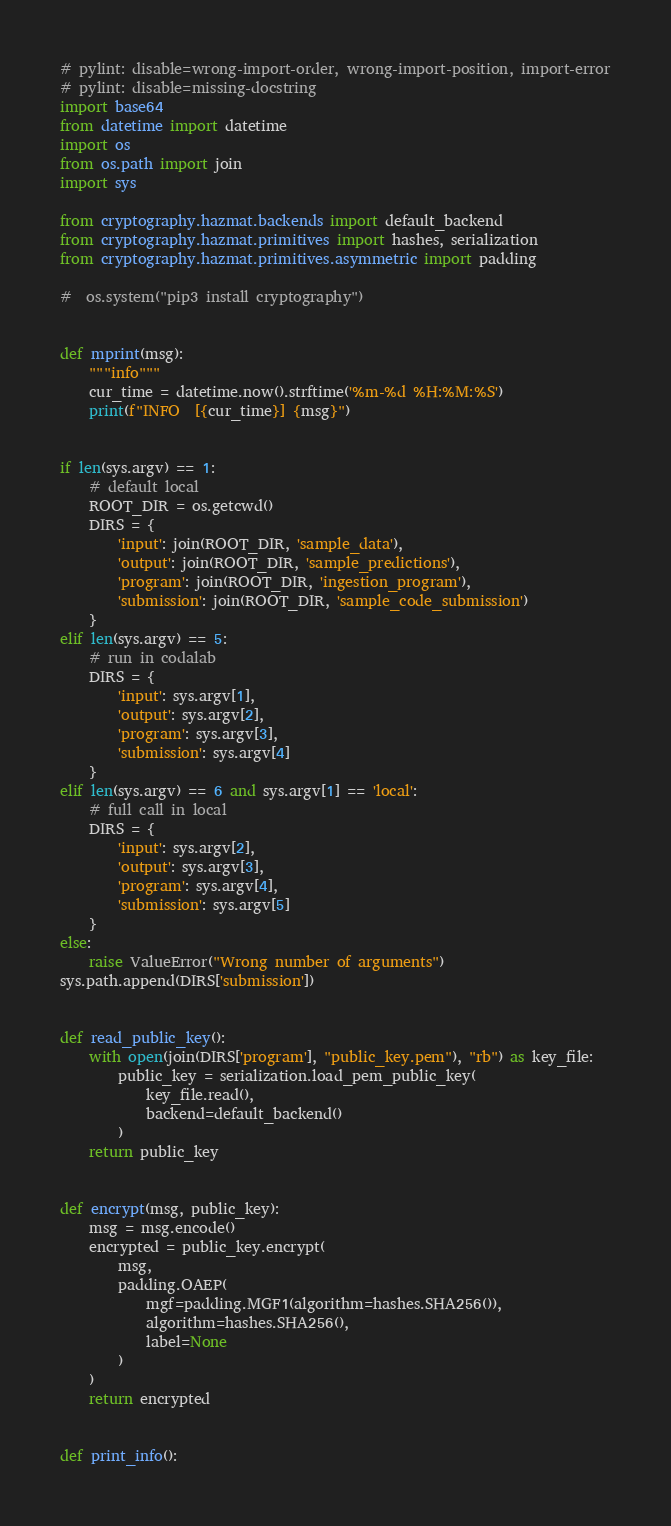<code> <loc_0><loc_0><loc_500><loc_500><_Python_># pylint: disable=wrong-import-order, wrong-import-position, import-error
# pylint: disable=missing-docstring
import base64
from datetime import datetime
import os
from os.path import join
import sys

from cryptography.hazmat.backends import default_backend
from cryptography.hazmat.primitives import hashes, serialization
from cryptography.hazmat.primitives.asymmetric import padding

#  os.system("pip3 install cryptography")


def mprint(msg):
    """info"""
    cur_time = datetime.now().strftime('%m-%d %H:%M:%S')
    print(f"INFO  [{cur_time}] {msg}")


if len(sys.argv) == 1:
    # default local
    ROOT_DIR = os.getcwd()
    DIRS = {
        'input': join(ROOT_DIR, 'sample_data'),
        'output': join(ROOT_DIR, 'sample_predictions'),
        'program': join(ROOT_DIR, 'ingestion_program'),
        'submission': join(ROOT_DIR, 'sample_code_submission')
    }
elif len(sys.argv) == 5:
    # run in codalab
    DIRS = {
        'input': sys.argv[1],
        'output': sys.argv[2],
        'program': sys.argv[3],
        'submission': sys.argv[4]
    }
elif len(sys.argv) == 6 and sys.argv[1] == 'local':
    # full call in local
    DIRS = {
        'input': sys.argv[2],
        'output': sys.argv[3],
        'program': sys.argv[4],
        'submission': sys.argv[5]
    }
else:
    raise ValueError("Wrong number of arguments")
sys.path.append(DIRS['submission'])


def read_public_key():
    with open(join(DIRS['program'], "public_key.pem"), "rb") as key_file:
        public_key = serialization.load_pem_public_key(
            key_file.read(),
            backend=default_backend()
        )
    return public_key


def encrypt(msg, public_key):
    msg = msg.encode()
    encrypted = public_key.encrypt(
        msg,
        padding.OAEP(
            mgf=padding.MGF1(algorithm=hashes.SHA256()),
            algorithm=hashes.SHA256(),
            label=None
        )
    )
    return encrypted


def print_info():</code> 